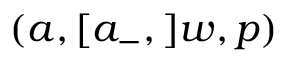<formula> <loc_0><loc_0><loc_500><loc_500>( a , [ a _ { - } , ] w , p )</formula> 